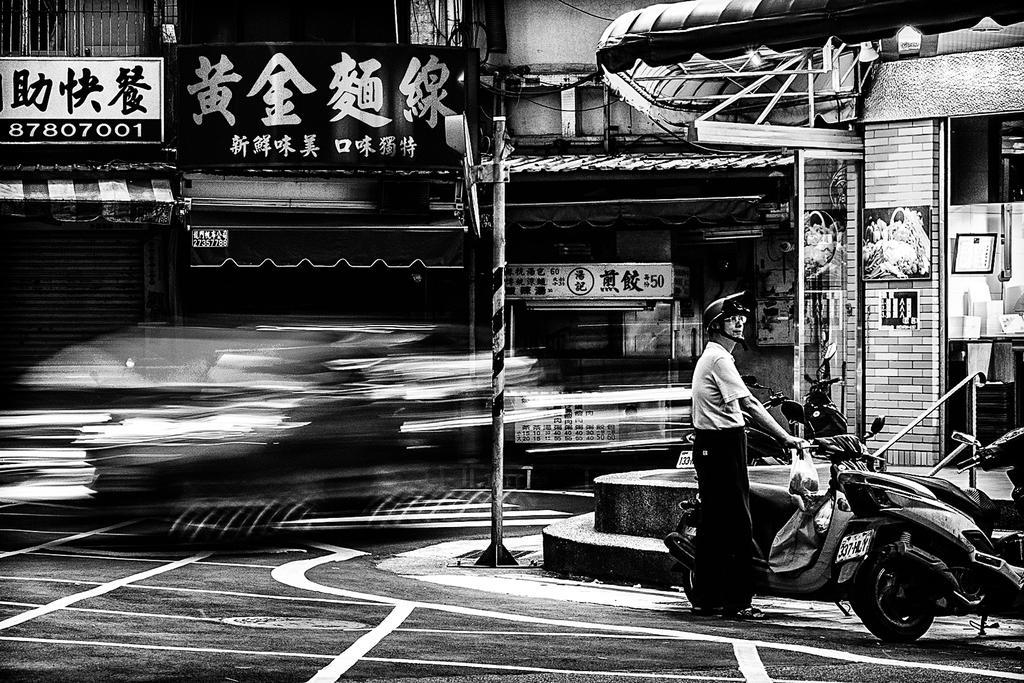How would you summarize this image in a sentence or two? In the bottom right corner of the image we can see some motorcycles and a person is standing. In the middle of the image we can see some poles, buildings and banners. Background of the image is blur. 